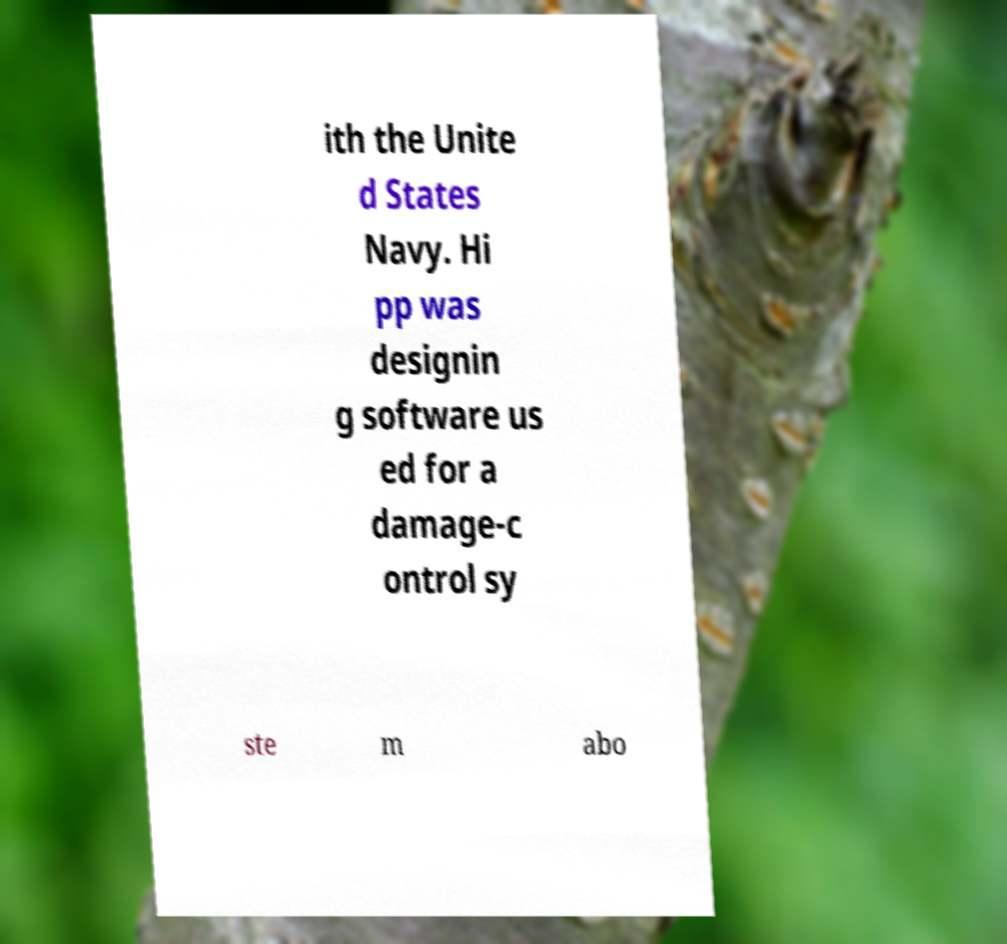What messages or text are displayed in this image? I need them in a readable, typed format. ith the Unite d States Navy. Hi pp was designin g software us ed for a damage-c ontrol sy ste m abo 